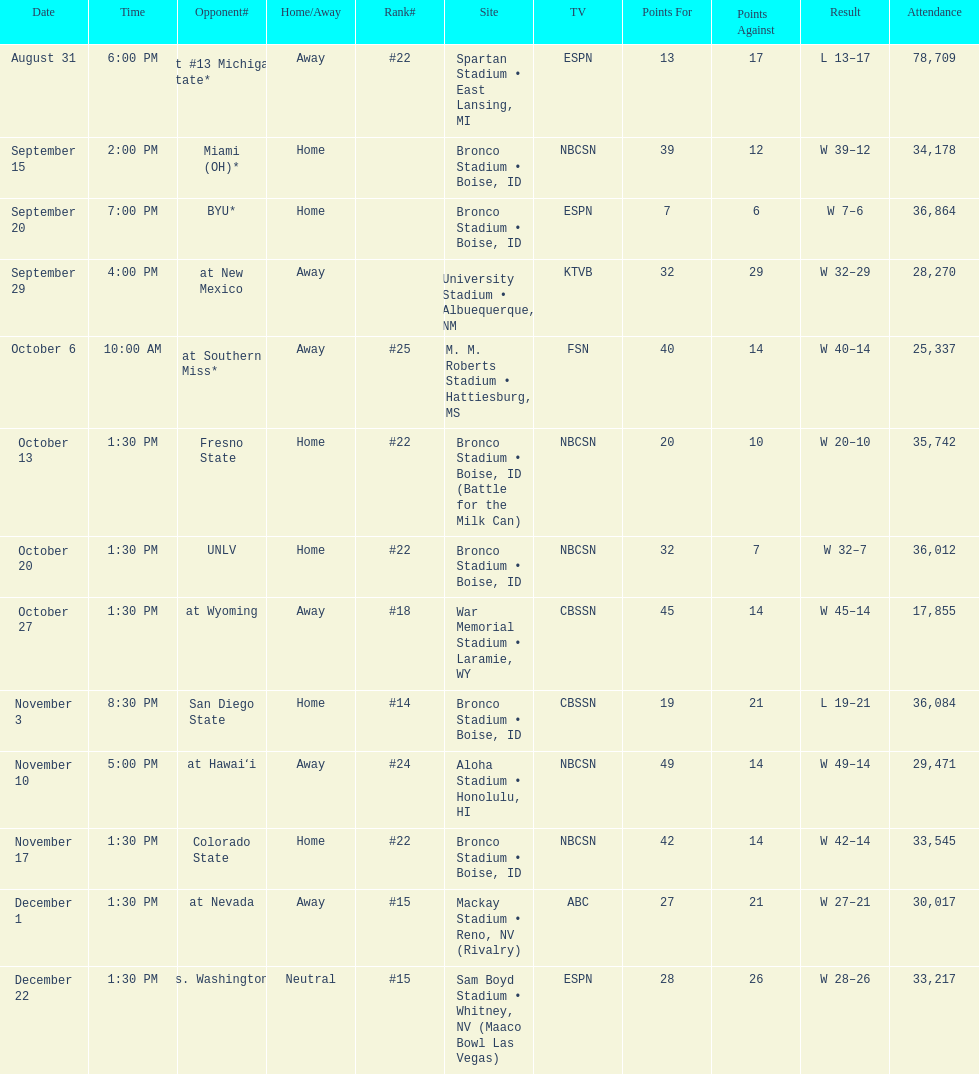How many points did miami (oh) score against the broncos? 12. Could you help me parse every detail presented in this table? {'header': ['Date', 'Time', 'Opponent#', 'Home/Away', 'Rank#', 'Site', 'TV', 'Points For', 'Points Against', 'Result', 'Attendance'], 'rows': [['August 31', '6:00 PM', 'at\xa0#13\xa0Michigan State*', 'Away', '#22', 'Spartan Stadium • East Lansing, MI', 'ESPN', '13', '17', 'L\xa013–17', '78,709'], ['September 15', '2:00 PM', 'Miami (OH)*', 'Home', '', 'Bronco Stadium • Boise, ID', 'NBCSN', '39', '12', 'W\xa039–12', '34,178'], ['September 20', '7:00 PM', 'BYU*', 'Home', '', 'Bronco Stadium • Boise, ID', 'ESPN', '7', '6', 'W\xa07–6', '36,864'], ['September 29', '4:00 PM', 'at\xa0New Mexico', 'Away', '', 'University Stadium • Albuequerque, NM', 'KTVB', '32', '29', 'W\xa032–29', '28,270'], ['October 6', '10:00 AM', 'at\xa0Southern Miss*', 'Away', '#25', 'M. M. Roberts Stadium • Hattiesburg, MS', 'FSN', '40', '14', 'W\xa040–14', '25,337'], ['October 13', '1:30 PM', 'Fresno State', 'Home', '#22', 'Bronco Stadium • Boise, ID (Battle for the Milk Can)', 'NBCSN', '20', '10', 'W\xa020–10', '35,742'], ['October 20', '1:30 PM', 'UNLV', 'Home', '#22', 'Bronco Stadium • Boise, ID', 'NBCSN', '32', '7', 'W\xa032–7', '36,012'], ['October 27', '1:30 PM', 'at\xa0Wyoming', 'Away', '#18', 'War Memorial Stadium • Laramie, WY', 'CBSSN', '45', '14', 'W\xa045–14', '17,855'], ['November 3', '8:30 PM', 'San Diego State', 'Home', '#14', 'Bronco Stadium • Boise, ID', 'CBSSN', '19', '21', 'L\xa019–21', '36,084'], ['November 10', '5:00 PM', 'at\xa0Hawaiʻi', 'Away', '#24', 'Aloha Stadium • Honolulu, HI', 'NBCSN', '49', '14', 'W\xa049–14', '29,471'], ['November 17', '1:30 PM', 'Colorado State', 'Home', '#22', 'Bronco Stadium • Boise, ID', 'NBCSN', '42', '14', 'W\xa042–14', '33,545'], ['December 1', '1:30 PM', 'at\xa0Nevada', 'Away', '#15', 'Mackay Stadium • Reno, NV (Rivalry)', 'ABC', '27', '21', 'W\xa027–21', '30,017'], ['December 22', '1:30 PM', 'vs.\xa0Washington*', 'Neutral', '#15', 'Sam Boyd Stadium • Whitney, NV (Maaco Bowl Las Vegas)', 'ESPN', '28', '26', 'W\xa028–26', '33,217']]} 